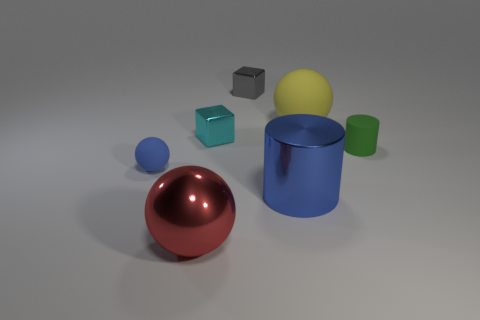How would you describe the lighting in this scene? The lighting appears to be diffuse with soft shadows, suggesting a light source that is either large or not too close to the objects, which gives the scene a calm and evenly lit appearance. 